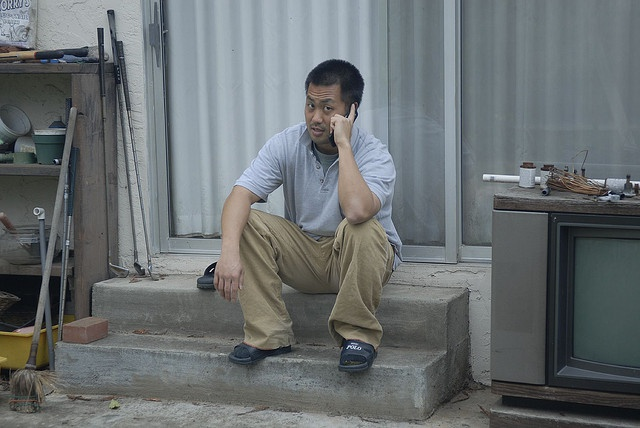Describe the objects in this image and their specific colors. I can see people in gray, darkgray, and black tones, tv in gray, black, and purple tones, and cell phone in gray, black, and navy tones in this image. 